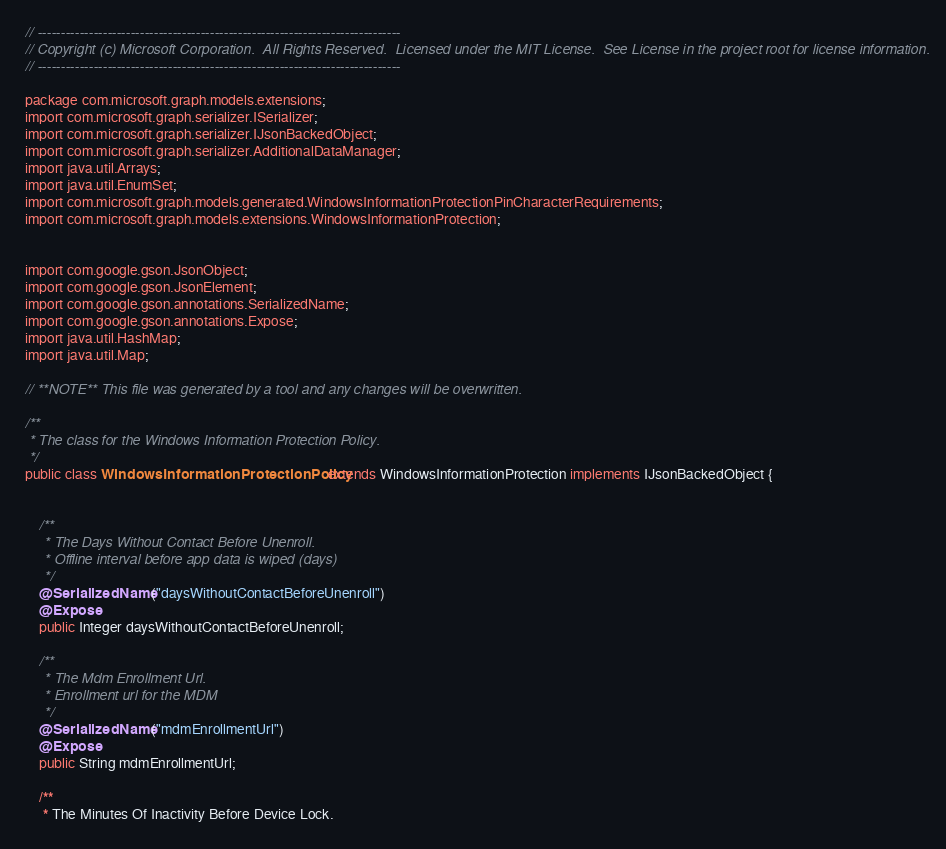<code> <loc_0><loc_0><loc_500><loc_500><_Java_>// ------------------------------------------------------------------------------
// Copyright (c) Microsoft Corporation.  All Rights Reserved.  Licensed under the MIT License.  See License in the project root for license information.
// ------------------------------------------------------------------------------

package com.microsoft.graph.models.extensions;
import com.microsoft.graph.serializer.ISerializer;
import com.microsoft.graph.serializer.IJsonBackedObject;
import com.microsoft.graph.serializer.AdditionalDataManager;
import java.util.Arrays;
import java.util.EnumSet;
import com.microsoft.graph.models.generated.WindowsInformationProtectionPinCharacterRequirements;
import com.microsoft.graph.models.extensions.WindowsInformationProtection;


import com.google.gson.JsonObject;
import com.google.gson.JsonElement;
import com.google.gson.annotations.SerializedName;
import com.google.gson.annotations.Expose;
import java.util.HashMap;
import java.util.Map;

// **NOTE** This file was generated by a tool and any changes will be overwritten.

/**
 * The class for the Windows Information Protection Policy.
 */
public class WindowsInformationProtectionPolicy extends WindowsInformationProtection implements IJsonBackedObject {


    /**
     * The Days Without Contact Before Unenroll.
     * Offline interval before app data is wiped (days)
     */
    @SerializedName("daysWithoutContactBeforeUnenroll")
    @Expose
    public Integer daysWithoutContactBeforeUnenroll;

    /**
     * The Mdm Enrollment Url.
     * Enrollment url for the MDM
     */
    @SerializedName("mdmEnrollmentUrl")
    @Expose
    public String mdmEnrollmentUrl;

    /**
     * The Minutes Of Inactivity Before Device Lock.</code> 